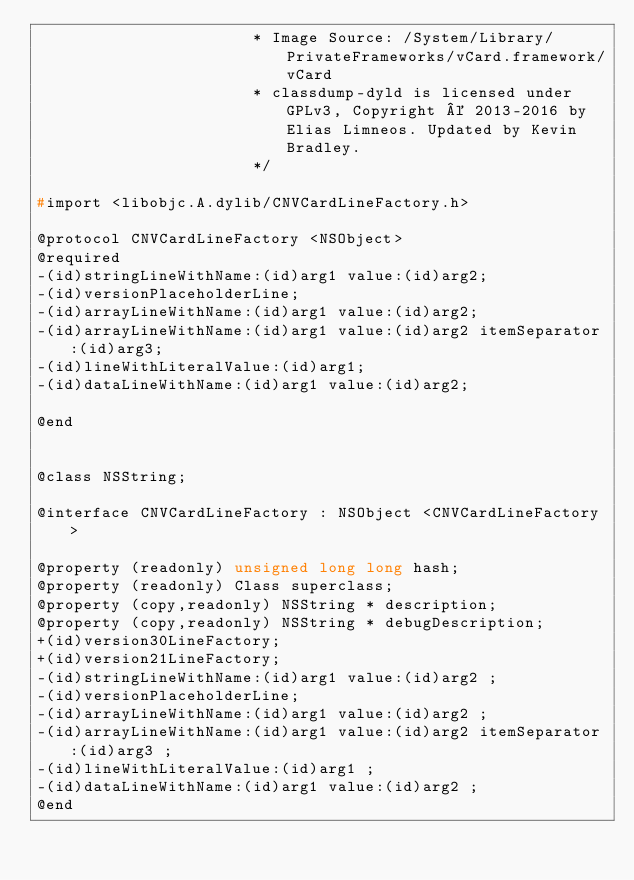Convert code to text. <code><loc_0><loc_0><loc_500><loc_500><_C_>                       * Image Source: /System/Library/PrivateFrameworks/vCard.framework/vCard
                       * classdump-dyld is licensed under GPLv3, Copyright © 2013-2016 by Elias Limneos. Updated by Kevin Bradley.
                       */

#import <libobjc.A.dylib/CNVCardLineFactory.h>

@protocol CNVCardLineFactory <NSObject>
@required
-(id)stringLineWithName:(id)arg1 value:(id)arg2;
-(id)versionPlaceholderLine;
-(id)arrayLineWithName:(id)arg1 value:(id)arg2;
-(id)arrayLineWithName:(id)arg1 value:(id)arg2 itemSeparator:(id)arg3;
-(id)lineWithLiteralValue:(id)arg1;
-(id)dataLineWithName:(id)arg1 value:(id)arg2;

@end


@class NSString;

@interface CNVCardLineFactory : NSObject <CNVCardLineFactory>

@property (readonly) unsigned long long hash; 
@property (readonly) Class superclass; 
@property (copy,readonly) NSString * description; 
@property (copy,readonly) NSString * debugDescription; 
+(id)version30LineFactory;
+(id)version21LineFactory;
-(id)stringLineWithName:(id)arg1 value:(id)arg2 ;
-(id)versionPlaceholderLine;
-(id)arrayLineWithName:(id)arg1 value:(id)arg2 ;
-(id)arrayLineWithName:(id)arg1 value:(id)arg2 itemSeparator:(id)arg3 ;
-(id)lineWithLiteralValue:(id)arg1 ;
-(id)dataLineWithName:(id)arg1 value:(id)arg2 ;
@end

</code> 